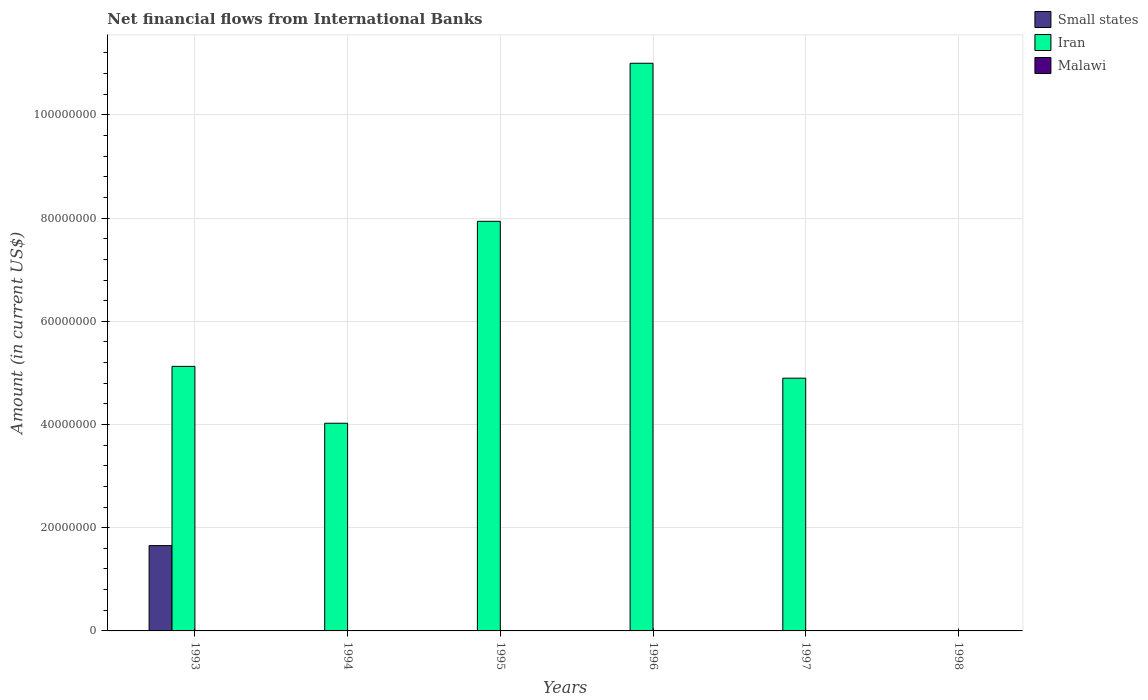How many different coloured bars are there?
Make the answer very short. 2. Are the number of bars per tick equal to the number of legend labels?
Your response must be concise. No. Are the number of bars on each tick of the X-axis equal?
Your answer should be compact. No. How many bars are there on the 2nd tick from the left?
Keep it short and to the point. 1. What is the label of the 1st group of bars from the left?
Your response must be concise. 1993. What is the net financial aid flows in Malawi in 1998?
Your answer should be compact. 0. Across all years, what is the maximum net financial aid flows in Iran?
Provide a succinct answer. 1.10e+08. Across all years, what is the minimum net financial aid flows in Malawi?
Your answer should be very brief. 0. What is the total net financial aid flows in Small states in the graph?
Ensure brevity in your answer.  1.65e+07. What is the difference between the net financial aid flows in Iran in 1995 and that in 1996?
Ensure brevity in your answer.  -3.06e+07. What is the average net financial aid flows in Iran per year?
Give a very brief answer. 5.50e+07. In the year 1993, what is the difference between the net financial aid flows in Iran and net financial aid flows in Small states?
Ensure brevity in your answer.  3.47e+07. What is the ratio of the net financial aid flows in Iran in 1995 to that in 1996?
Make the answer very short. 0.72. Is the net financial aid flows in Iran in 1995 less than that in 1997?
Your answer should be very brief. No. What is the difference between the highest and the second highest net financial aid flows in Iran?
Offer a terse response. 3.06e+07. What is the difference between the highest and the lowest net financial aid flows in Iran?
Your answer should be compact. 1.10e+08. In how many years, is the net financial aid flows in Malawi greater than the average net financial aid flows in Malawi taken over all years?
Provide a short and direct response. 0. How many years are there in the graph?
Your answer should be compact. 6. What is the difference between two consecutive major ticks on the Y-axis?
Your response must be concise. 2.00e+07. Does the graph contain grids?
Your response must be concise. Yes. How are the legend labels stacked?
Your response must be concise. Vertical. What is the title of the graph?
Ensure brevity in your answer.  Net financial flows from International Banks. What is the label or title of the X-axis?
Offer a terse response. Years. What is the Amount (in current US$) of Small states in 1993?
Your answer should be compact. 1.65e+07. What is the Amount (in current US$) in Iran in 1993?
Give a very brief answer. 5.13e+07. What is the Amount (in current US$) of Malawi in 1993?
Your answer should be very brief. 0. What is the Amount (in current US$) in Iran in 1994?
Your answer should be very brief. 4.02e+07. What is the Amount (in current US$) in Iran in 1995?
Your response must be concise. 7.94e+07. What is the Amount (in current US$) in Iran in 1996?
Your answer should be compact. 1.10e+08. What is the Amount (in current US$) of Iran in 1997?
Offer a terse response. 4.90e+07. What is the Amount (in current US$) of Malawi in 1998?
Your answer should be very brief. 0. Across all years, what is the maximum Amount (in current US$) of Small states?
Offer a very short reply. 1.65e+07. Across all years, what is the maximum Amount (in current US$) in Iran?
Ensure brevity in your answer.  1.10e+08. Across all years, what is the minimum Amount (in current US$) in Small states?
Provide a succinct answer. 0. Across all years, what is the minimum Amount (in current US$) of Iran?
Give a very brief answer. 0. What is the total Amount (in current US$) of Small states in the graph?
Ensure brevity in your answer.  1.65e+07. What is the total Amount (in current US$) of Iran in the graph?
Provide a short and direct response. 3.30e+08. What is the total Amount (in current US$) in Malawi in the graph?
Keep it short and to the point. 0. What is the difference between the Amount (in current US$) of Iran in 1993 and that in 1994?
Your answer should be compact. 1.10e+07. What is the difference between the Amount (in current US$) in Iran in 1993 and that in 1995?
Ensure brevity in your answer.  -2.81e+07. What is the difference between the Amount (in current US$) of Iran in 1993 and that in 1996?
Keep it short and to the point. -5.87e+07. What is the difference between the Amount (in current US$) in Iran in 1993 and that in 1997?
Your response must be concise. 2.29e+06. What is the difference between the Amount (in current US$) in Iran in 1994 and that in 1995?
Your answer should be very brief. -3.91e+07. What is the difference between the Amount (in current US$) in Iran in 1994 and that in 1996?
Offer a very short reply. -6.98e+07. What is the difference between the Amount (in current US$) of Iran in 1994 and that in 1997?
Ensure brevity in your answer.  -8.73e+06. What is the difference between the Amount (in current US$) in Iran in 1995 and that in 1996?
Ensure brevity in your answer.  -3.06e+07. What is the difference between the Amount (in current US$) of Iran in 1995 and that in 1997?
Ensure brevity in your answer.  3.04e+07. What is the difference between the Amount (in current US$) in Iran in 1996 and that in 1997?
Your answer should be very brief. 6.10e+07. What is the difference between the Amount (in current US$) of Small states in 1993 and the Amount (in current US$) of Iran in 1994?
Your response must be concise. -2.37e+07. What is the difference between the Amount (in current US$) in Small states in 1993 and the Amount (in current US$) in Iran in 1995?
Your answer should be very brief. -6.28e+07. What is the difference between the Amount (in current US$) of Small states in 1993 and the Amount (in current US$) of Iran in 1996?
Make the answer very short. -9.35e+07. What is the difference between the Amount (in current US$) in Small states in 1993 and the Amount (in current US$) in Iran in 1997?
Keep it short and to the point. -3.24e+07. What is the average Amount (in current US$) in Small states per year?
Provide a succinct answer. 2.76e+06. What is the average Amount (in current US$) of Iran per year?
Your answer should be compact. 5.50e+07. What is the average Amount (in current US$) in Malawi per year?
Make the answer very short. 0. In the year 1993, what is the difference between the Amount (in current US$) in Small states and Amount (in current US$) in Iran?
Your answer should be very brief. -3.47e+07. What is the ratio of the Amount (in current US$) of Iran in 1993 to that in 1994?
Offer a very short reply. 1.27. What is the ratio of the Amount (in current US$) of Iran in 1993 to that in 1995?
Your response must be concise. 0.65. What is the ratio of the Amount (in current US$) of Iran in 1993 to that in 1996?
Your response must be concise. 0.47. What is the ratio of the Amount (in current US$) in Iran in 1993 to that in 1997?
Give a very brief answer. 1.05. What is the ratio of the Amount (in current US$) of Iran in 1994 to that in 1995?
Provide a succinct answer. 0.51. What is the ratio of the Amount (in current US$) in Iran in 1994 to that in 1996?
Your response must be concise. 0.37. What is the ratio of the Amount (in current US$) of Iran in 1994 to that in 1997?
Ensure brevity in your answer.  0.82. What is the ratio of the Amount (in current US$) of Iran in 1995 to that in 1996?
Provide a short and direct response. 0.72. What is the ratio of the Amount (in current US$) in Iran in 1995 to that in 1997?
Your answer should be very brief. 1.62. What is the ratio of the Amount (in current US$) in Iran in 1996 to that in 1997?
Make the answer very short. 2.25. What is the difference between the highest and the second highest Amount (in current US$) of Iran?
Offer a very short reply. 3.06e+07. What is the difference between the highest and the lowest Amount (in current US$) of Small states?
Your response must be concise. 1.65e+07. What is the difference between the highest and the lowest Amount (in current US$) in Iran?
Offer a terse response. 1.10e+08. 